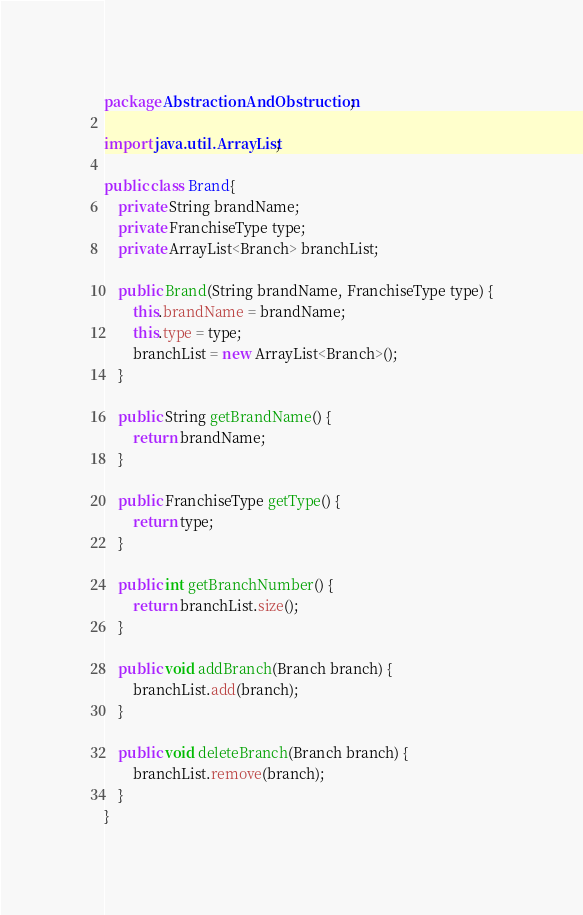<code> <loc_0><loc_0><loc_500><loc_500><_Java_>package AbstractionAndObstruction;

import java.util.ArrayList;

public class Brand{
    private String brandName;
    private FranchiseType type;
    private ArrayList<Branch> branchList;

    public Brand(String brandName, FranchiseType type) {
        this.brandName = brandName;
        this.type = type;
        branchList = new ArrayList<Branch>();
    }

    public String getBrandName() {
        return brandName;
    }

    public FranchiseType getType() {
        return type;
    }

    public int getBranchNumber() {
        return branchList.size();
    }

    public void addBranch(Branch branch) {
        branchList.add(branch);
    }

    public void deleteBranch(Branch branch) {
        branchList.remove(branch);
    }
}

</code> 